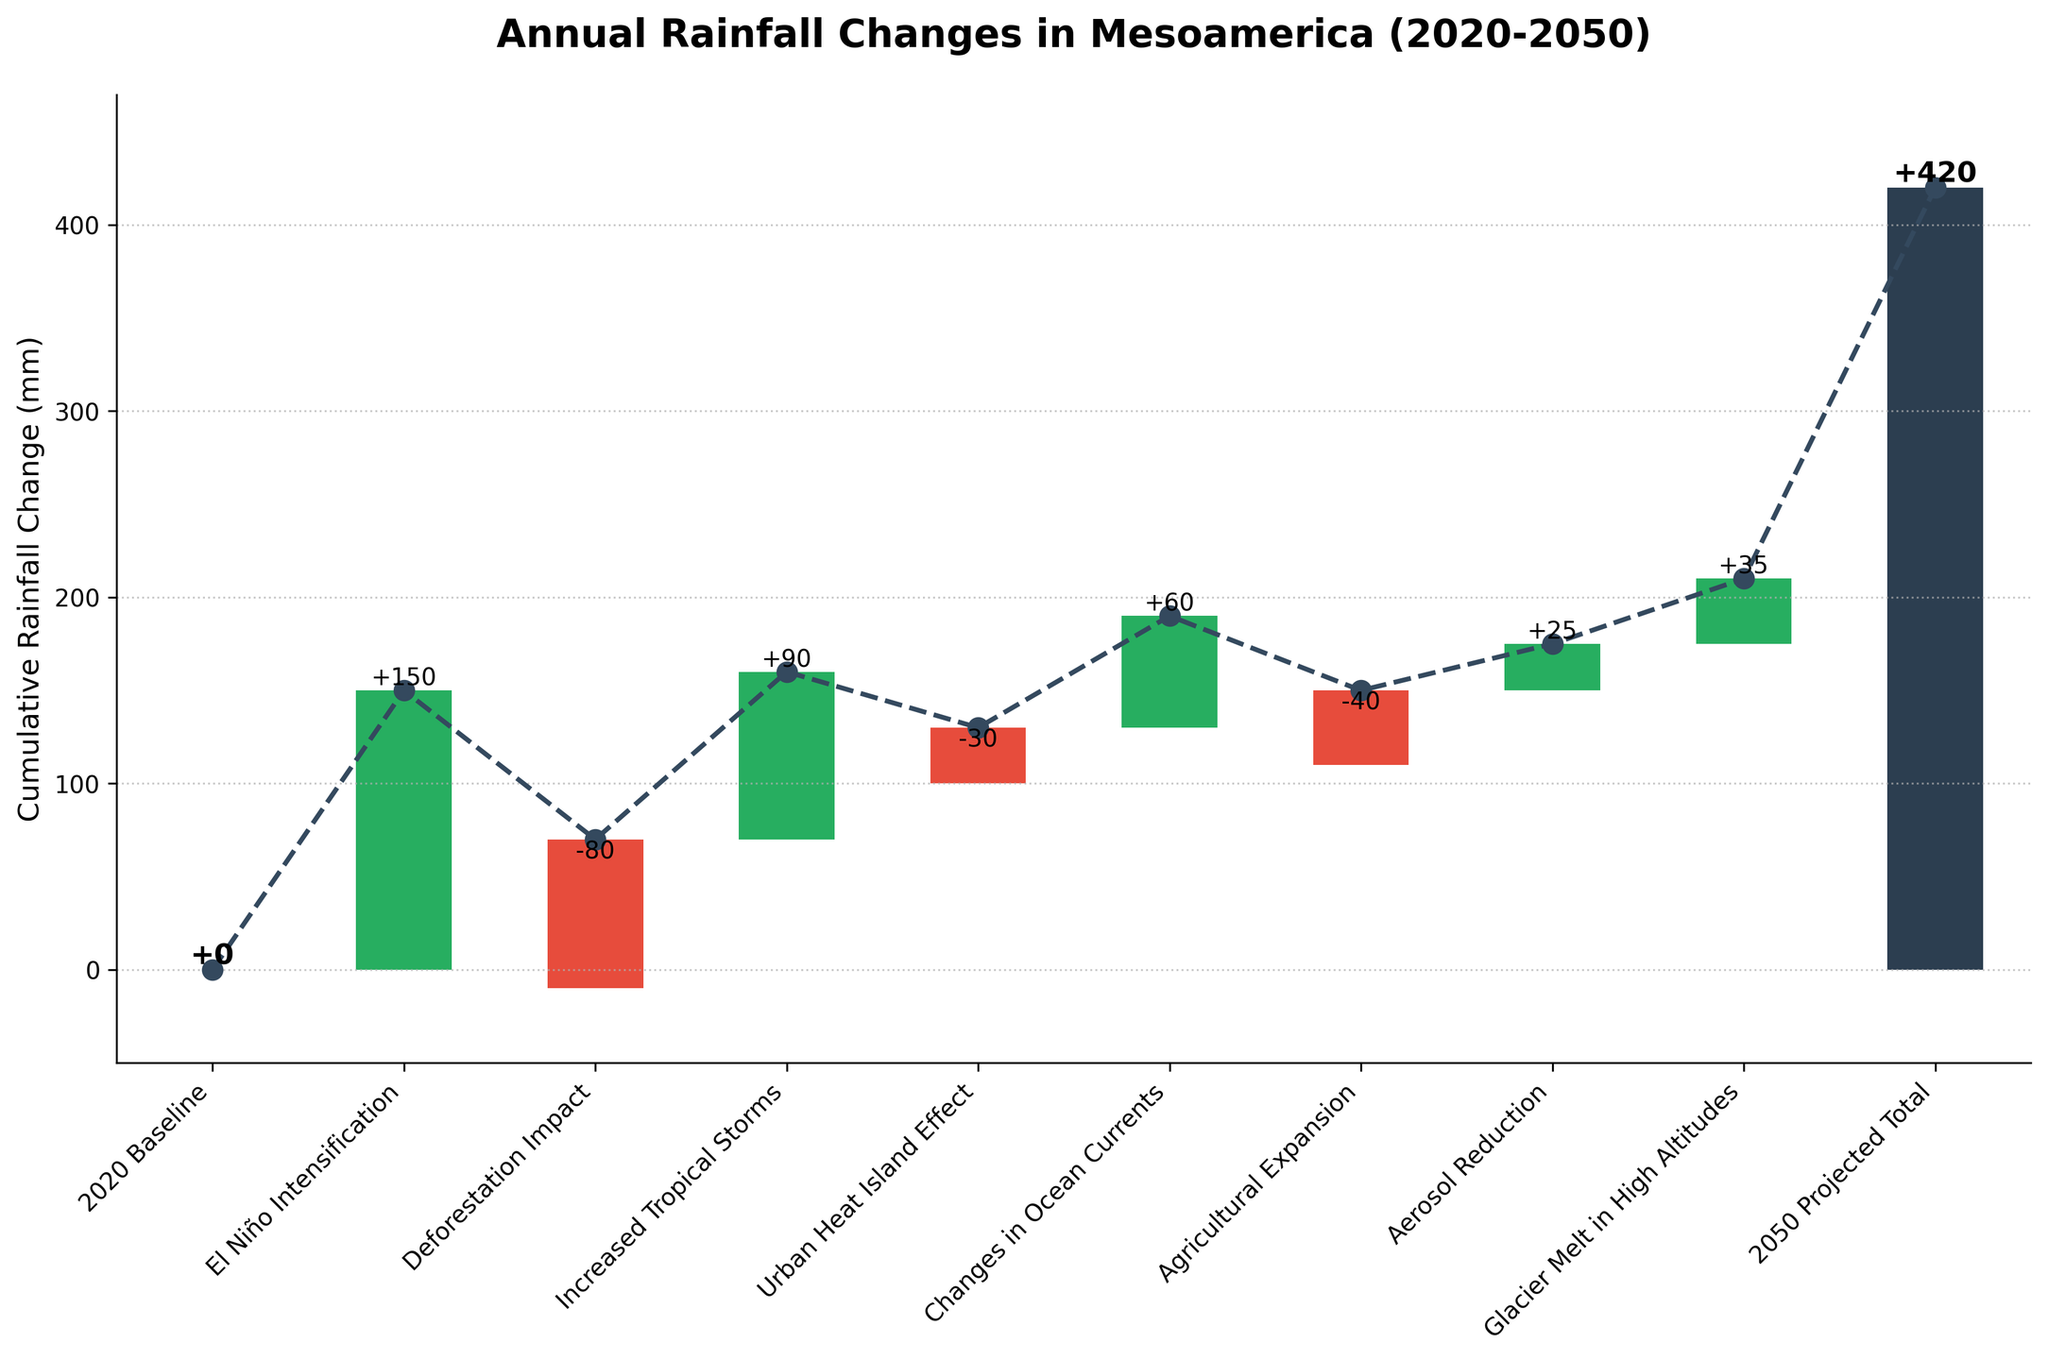What's the title of the chart? The title of the chart is displayed at the top and reads "Annual Rainfall Changes in Mesoamerica (2020-2050)", which provides an overview of what the chart is depicting.
Answer: Annual Rainfall Changes in Mesoamerica (2020-2050) What does the bar for 'El Niño Intensification' represent? The bar for 'El Niño Intensification' is a positive green bar showing an increase in cumulative rainfall. From the data, it adds 150 mm to the baseline.
Answer: 150 mm Which factor has the largest negative impact on rainfall? By looking at the length and direction of the red bars, the 'Deforestation Impact' is the largest negative contributor, as it decreases the cumulative rainfall by 80 mm.
Answer: Deforestation Impact What is the cumulative rainfall change by the 'Urban Heat Island Effect'? The cumulative rainfall change by the 'Urban Heat Island Effect' can be found by summing the prior changes: 0 + 150 - 80 + 90 = 160 mm, and then adding the Urban Heat Island Effect impact: 160 - 30 = 130 mm.
Answer: 130 mm What is the net effect of all negative factors? The negative factors are 'Deforestation Impact' (-80 mm), 'Urban Heat Island Effect' (-30 mm), and 'Agricultural Expansion' (-40 mm). Adding these gives -80 -30 -40 = -150 mm.
Answer: -150 mm How does the '2050 Projected Total' compare to the '2020 Baseline'? The '2050 Projected Total' can be directly observed from the final bar, which represents an increase of 210 mm compared to the '2020 Baseline'.
Answer: 210 mm What's the effect of 'Aerosol Reduction' on cumulative rainfall? The effect of 'Aerosol Reduction' is a positive bar contributing to an increase of 25 mm to the cumulative rainfall.
Answer: 25 mm Do positive factors outweigh negative factors in terms of rainfall change? We compare cumulative positive changes: 150 (El Niño) + 90 (Tropical Storms) + 60 (Ocean Currents) + 25 (Aerosol Reduction) + 35 (Glacier Melt) = 360 mm and negative changes: -80 (Deforestation) -30 (Urban Heat Island) -40 (Agricultural Expansion) = -150 mm; positive outweigh as 360 > 150.
Answer: Yes Which factor contributes more to the cumulative rainfall, 'Glacier Melt in High Altitudes' or 'Aerosol Reduction'? Compare the green bars of both factors; 'Glacier Melt in High Altitudes' adds 35 mm, whereas 'Aerosol Reduction' adds 25 mm. Glacier Melt is greater.
Answer: Glacier Melt in High Altitudes How much is the cumulative effect after the 'Increased Tropical Storms'? Adding up the baseline and impacts up to 'Increased Tropical Storms': 0 (2020 Baseline) + 150 (El Niño Intensification) - 80 (Deforestation Impact) + 90 (Increased Tropical Storms) = 160 mm.
Answer: 160 mm 